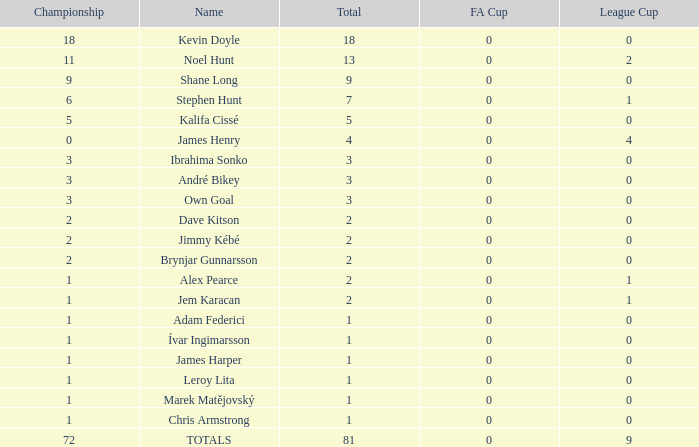What is the total championships of James Henry that has a league cup more than 1? 0.0. 